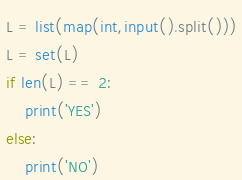Convert code to text. <code><loc_0><loc_0><loc_500><loc_500><_Python_>L = list(map(int,input().split()))
L = set(L)
if len(L) == 2:
    print('YES')
else:
    print('NO')
</code> 